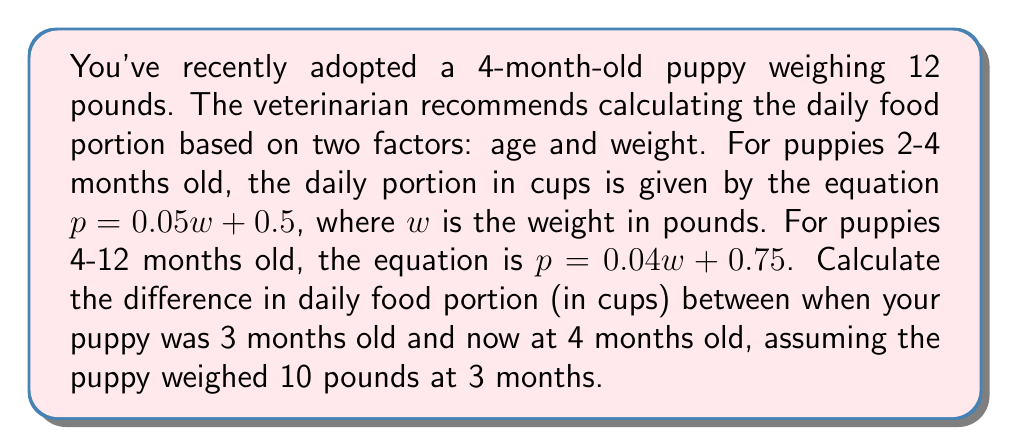Provide a solution to this math problem. Let's approach this step-by-step:

1. Calculate the food portion for the puppy at 3 months (10 pounds):
   Using the equation for 2-4 months: $p = 0.05w + 0.5$
   $$p = 0.05(10) + 0.5 = 0.5 + 0.5 = 1$$

2. Calculate the food portion for the puppy at 4 months (12 pounds):
   Using the equation for 4-12 months: $p = 0.04w + 0.75$
   $$p = 0.04(12) + 0.75 = 0.48 + 0.75 = 1.23$$

3. Calculate the difference:
   $$\text{Difference} = 1.23 - 1 = 0.23$$

Therefore, the difference in daily food portion between 3 months and 4 months is 0.23 cups.
Answer: 0.23 cups 